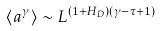<formula> <loc_0><loc_0><loc_500><loc_500>\langle a ^ { \gamma } \rangle \sim L ^ { ( 1 + H _ { D } ) ( \gamma - \tau + 1 ) }</formula> 